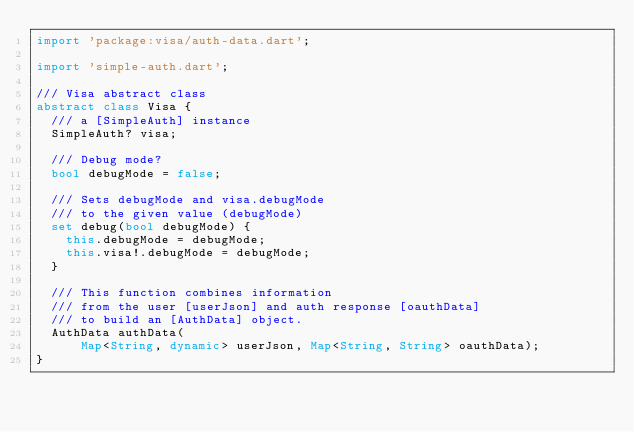Convert code to text. <code><loc_0><loc_0><loc_500><loc_500><_Dart_>import 'package:visa/auth-data.dart';

import 'simple-auth.dart';

/// Visa abstract class
abstract class Visa {
  /// a [SimpleAuth] instance
  SimpleAuth? visa;

  /// Debug mode?
  bool debugMode = false;

  /// Sets debugMode and visa.debugMode
  /// to the given value (debugMode)
  set debug(bool debugMode) {
    this.debugMode = debugMode;
    this.visa!.debugMode = debugMode;
  }

  /// This function combines information
  /// from the user [userJson] and auth response [oauthData]
  /// to build an [AuthData] object.
  AuthData authData(
      Map<String, dynamic> userJson, Map<String, String> oauthData);
}
</code> 